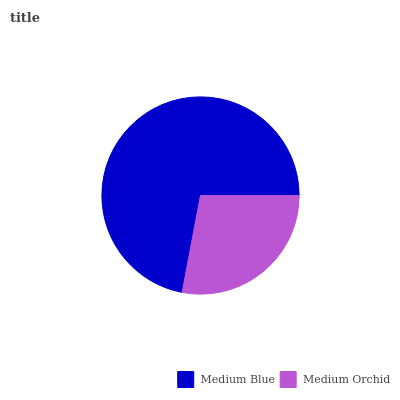Is Medium Orchid the minimum?
Answer yes or no. Yes. Is Medium Blue the maximum?
Answer yes or no. Yes. Is Medium Orchid the maximum?
Answer yes or no. No. Is Medium Blue greater than Medium Orchid?
Answer yes or no. Yes. Is Medium Orchid less than Medium Blue?
Answer yes or no. Yes. Is Medium Orchid greater than Medium Blue?
Answer yes or no. No. Is Medium Blue less than Medium Orchid?
Answer yes or no. No. Is Medium Blue the high median?
Answer yes or no. Yes. Is Medium Orchid the low median?
Answer yes or no. Yes. Is Medium Orchid the high median?
Answer yes or no. No. Is Medium Blue the low median?
Answer yes or no. No. 